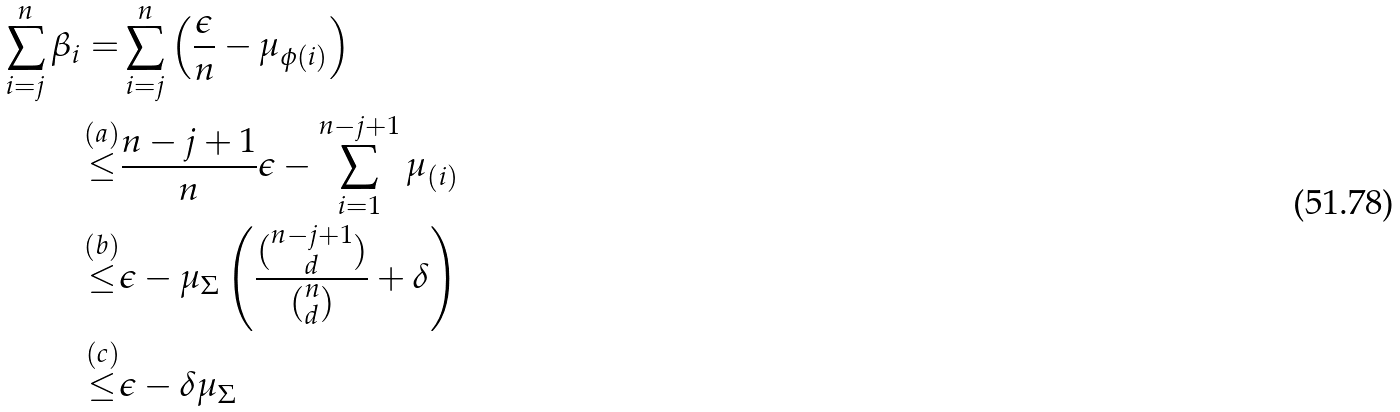<formula> <loc_0><loc_0><loc_500><loc_500>\sum _ { i = j } ^ { n } \beta _ { i } = & \sum _ { i = j } ^ { n } \left ( \frac { \epsilon } { n } - \mu _ { \phi ( i ) } \right ) \\ \stackrel { ( a ) } { \leq } & \frac { n - j + 1 } { n } \epsilon - \sum _ { i = 1 } ^ { n - j + 1 } \mu _ { ( i ) } \\ \stackrel { ( b ) } { \leq } & \epsilon - \mu _ { \Sigma } \left ( \frac { \binom { n - j + 1 } { d } } { \binom { n } { d } } + \delta \right ) \\ \stackrel { ( c ) } { \leq } & \epsilon - \delta \mu _ { \Sigma }</formula> 